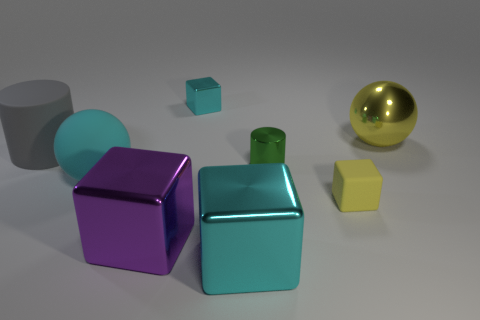Subtract all small cyan cubes. How many cubes are left? 3 Add 1 large metal spheres. How many objects exist? 9 Add 8 small green metallic cylinders. How many small green metallic cylinders are left? 9 Add 4 large cyan rubber objects. How many large cyan rubber objects exist? 5 Subtract all purple cubes. How many cubes are left? 3 Subtract 0 gray cubes. How many objects are left? 8 Subtract all balls. How many objects are left? 6 Subtract 1 blocks. How many blocks are left? 3 Subtract all cyan balls. Subtract all green blocks. How many balls are left? 1 Subtract all purple spheres. How many gray cubes are left? 0 